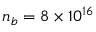Convert formula to latex. <formula><loc_0><loc_0><loc_500><loc_500>n _ { b } = 8 \times 1 0 ^ { 1 6 }</formula> 